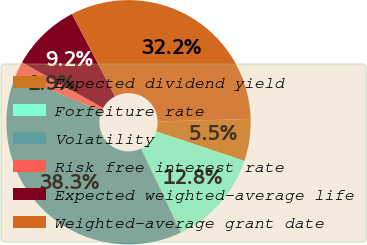<chart> <loc_0><loc_0><loc_500><loc_500><pie_chart><fcel>Expected dividend yield<fcel>Forfeiture rate<fcel>Volatility<fcel>Risk free interest rate<fcel>Expected weighted-average life<fcel>Weighted-average grant date<nl><fcel>5.55%<fcel>12.82%<fcel>38.31%<fcel>1.91%<fcel>9.19%<fcel>32.23%<nl></chart> 